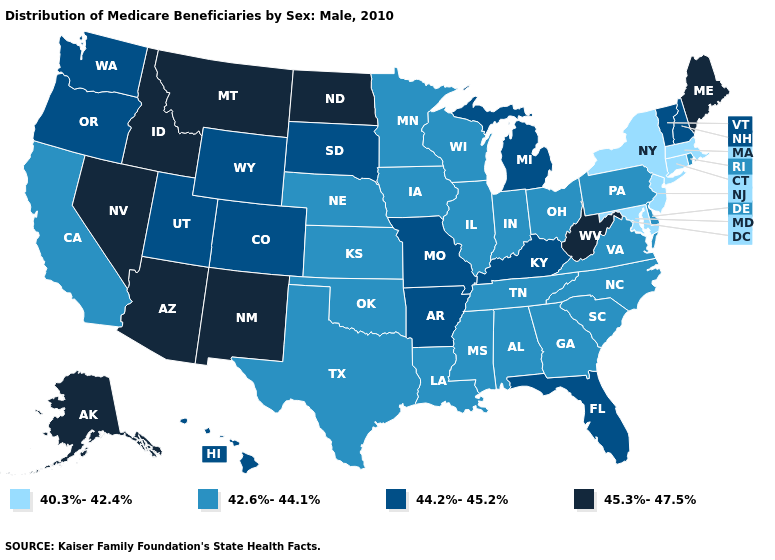Among the states that border North Dakota , which have the highest value?
Short answer required. Montana. What is the highest value in the USA?
Short answer required. 45.3%-47.5%. Name the states that have a value in the range 42.6%-44.1%?
Write a very short answer. Alabama, California, Delaware, Georgia, Illinois, Indiana, Iowa, Kansas, Louisiana, Minnesota, Mississippi, Nebraska, North Carolina, Ohio, Oklahoma, Pennsylvania, Rhode Island, South Carolina, Tennessee, Texas, Virginia, Wisconsin. Which states have the lowest value in the Northeast?
Be succinct. Connecticut, Massachusetts, New Jersey, New York. Does the first symbol in the legend represent the smallest category?
Be succinct. Yes. What is the lowest value in states that border Pennsylvania?
Concise answer only. 40.3%-42.4%. Does Utah have the same value as New Hampshire?
Short answer required. Yes. Which states have the lowest value in the South?
Answer briefly. Maryland. Among the states that border New Jersey , which have the lowest value?
Quick response, please. New York. Does the first symbol in the legend represent the smallest category?
Be succinct. Yes. What is the value of New Mexico?
Concise answer only. 45.3%-47.5%. What is the highest value in the USA?
Write a very short answer. 45.3%-47.5%. What is the lowest value in the USA?
Keep it brief. 40.3%-42.4%. Does South Dakota have the highest value in the MidWest?
Be succinct. No. 